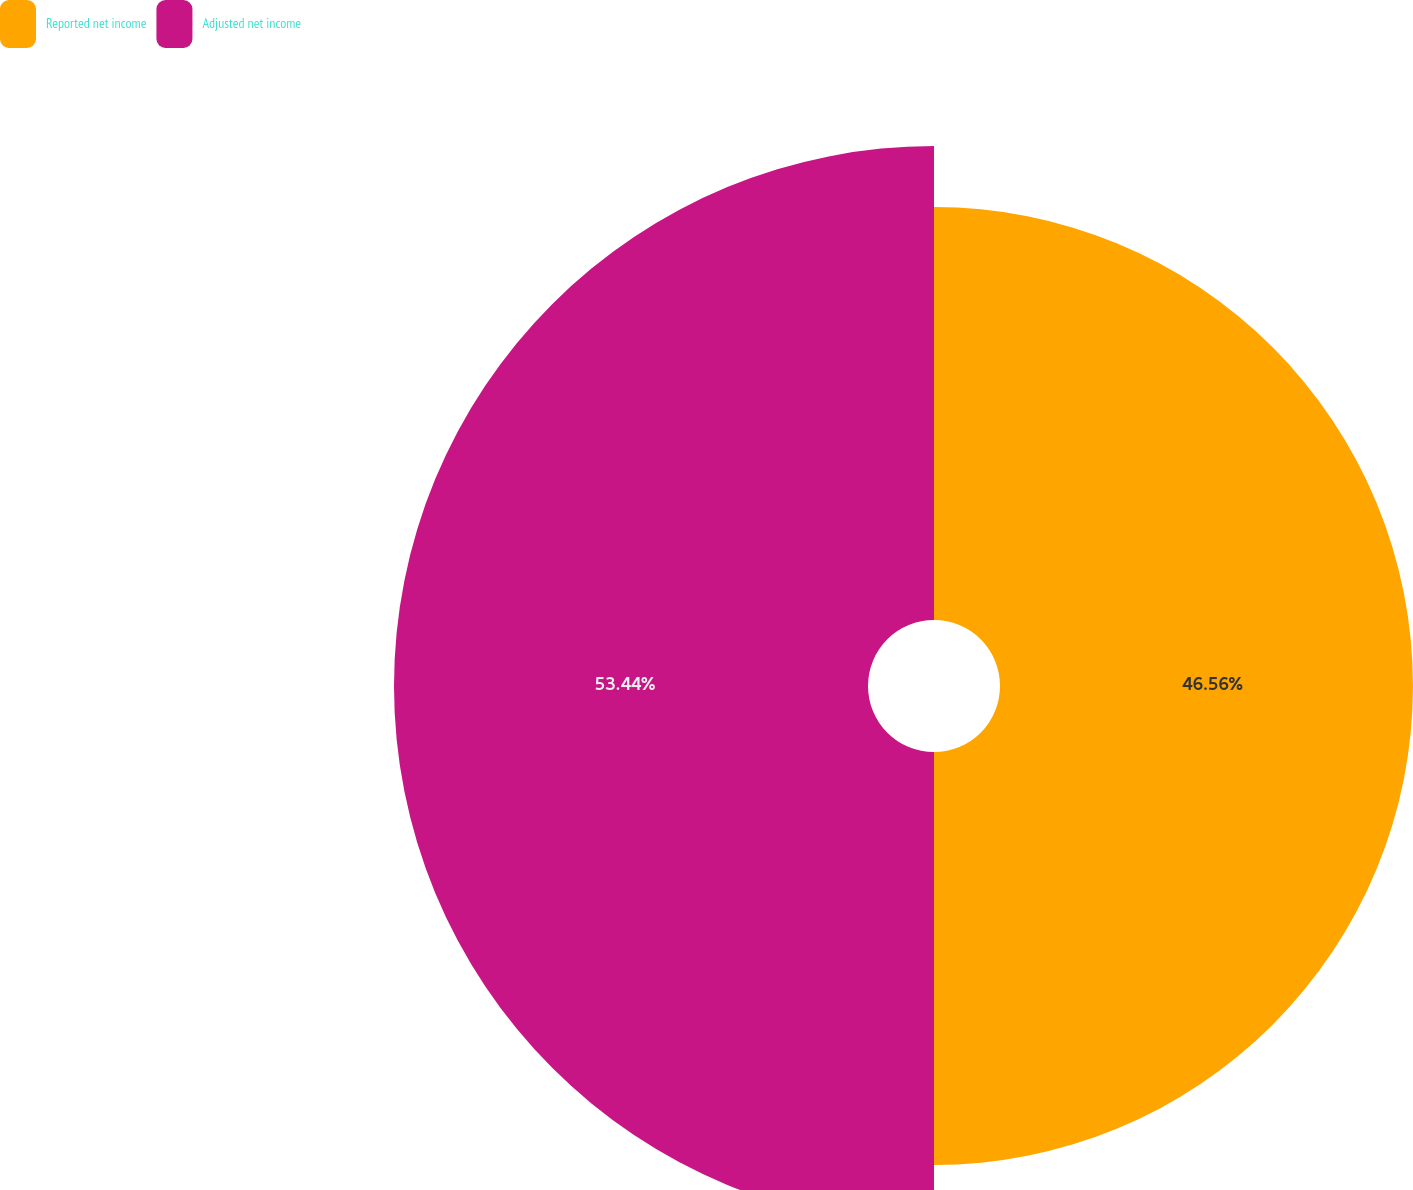<chart> <loc_0><loc_0><loc_500><loc_500><pie_chart><fcel>Reported net income<fcel>Adjusted net income<nl><fcel>46.56%<fcel>53.44%<nl></chart> 